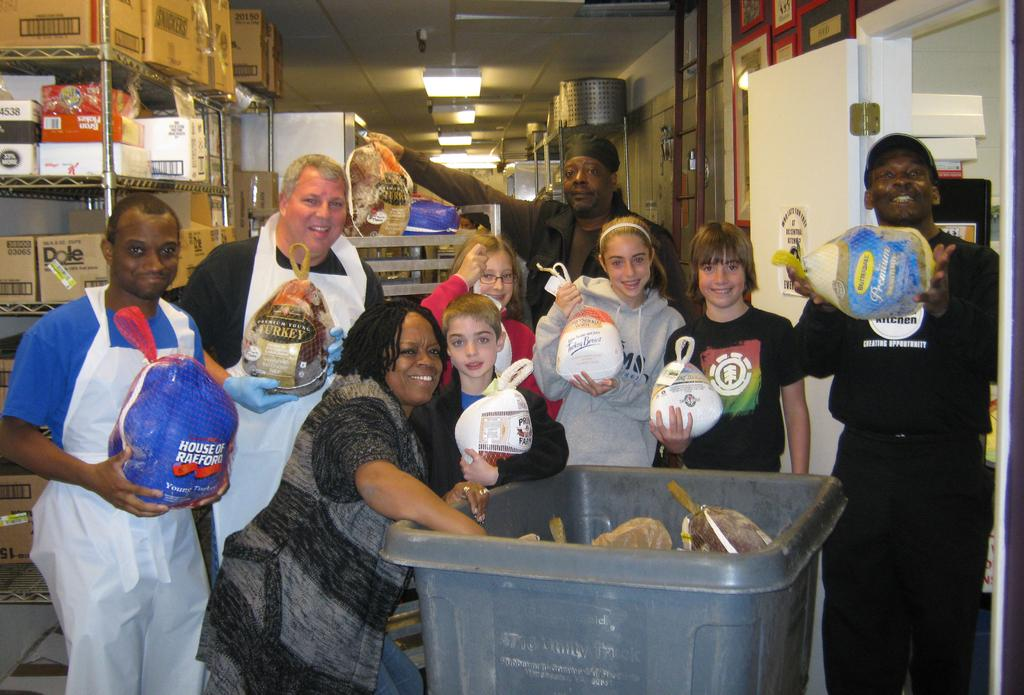What are the people in the image doing? The people in the image are standing and holding objects. What can be seen on the shelf in the image? There are boxes on a shelf in the image. What is above the people in the image? There is a roof with lights in the image. Is there any entrance or exit visible in the image? Yes, there is a door in the image. What type of egg is being used to water the plantation in the image? There is no egg or plantation present in the image. What is the key used for in the image? There is no key present in the image. 